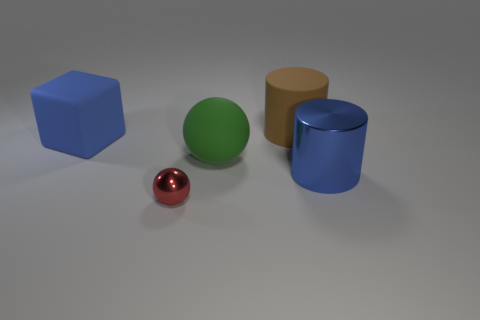Are there any small things of the same shape as the big brown object?
Provide a succinct answer. No. Do the blue thing that is on the left side of the small red shiny thing and the blue object to the right of the matte cylinder have the same size?
Keep it short and to the point. Yes. Are there fewer large blue matte objects behind the large brown thing than small red shiny balls that are to the left of the tiny metal thing?
Your answer should be compact. No. What material is the big object that is the same color as the metallic cylinder?
Ensure brevity in your answer.  Rubber. There is a big thing on the left side of the big matte ball; what is its color?
Your answer should be compact. Blue. Do the large metal object and the tiny metallic thing have the same color?
Keep it short and to the point. No. There is a ball that is in front of the blue thing to the right of the big blue matte block; what number of large brown cylinders are left of it?
Keep it short and to the point. 0. The blue cylinder has what size?
Offer a very short reply. Large. There is a blue cylinder that is the same size as the rubber ball; what is it made of?
Ensure brevity in your answer.  Metal. What number of green spheres are in front of the brown rubber object?
Your answer should be very brief. 1. 